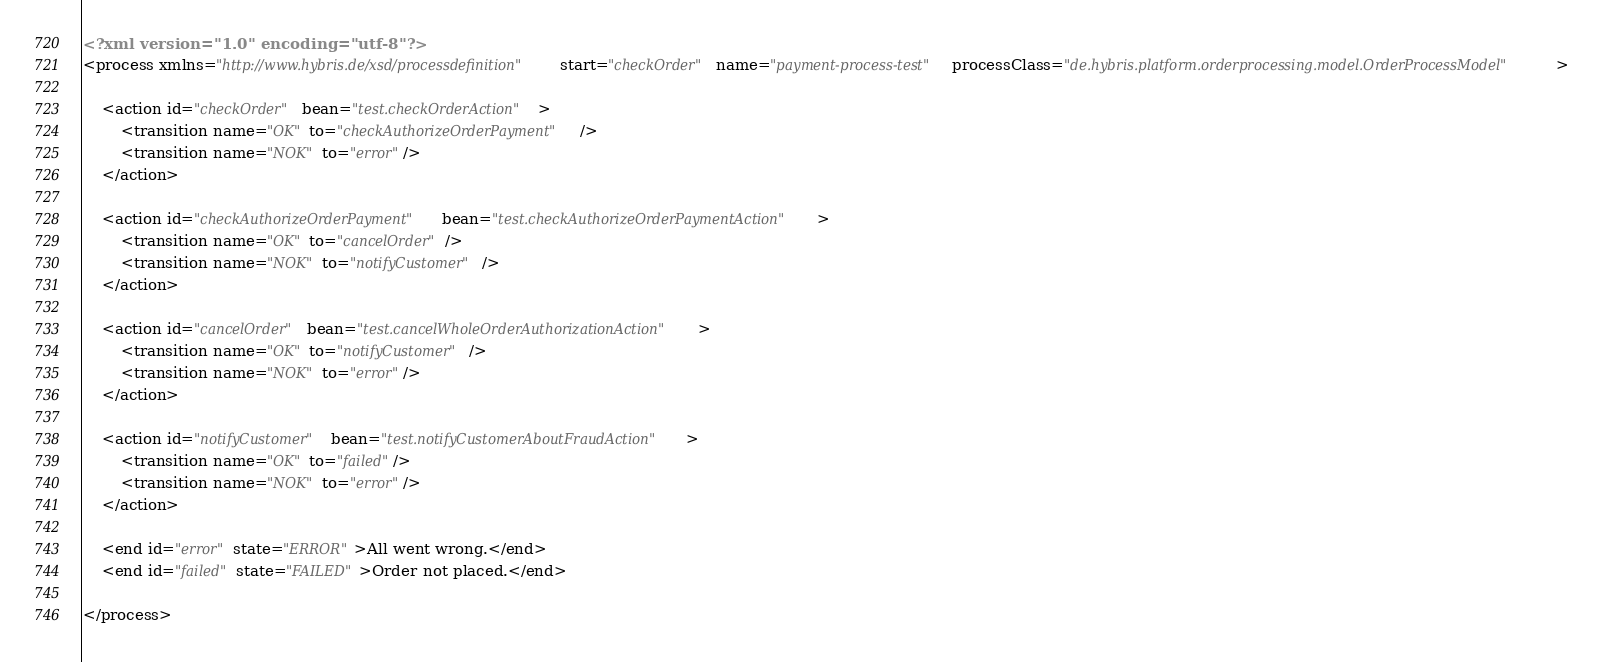Convert code to text. <code><loc_0><loc_0><loc_500><loc_500><_XML_><?xml version="1.0" encoding="utf-8"?>
<process xmlns="http://www.hybris.de/xsd/processdefinition" start="checkOrder" name="payment-process-test" processClass="de.hybris.platform.orderprocessing.model.OrderProcessModel">

	<action id="checkOrder" bean="test.checkOrderAction">
		<transition name="OK" to="checkAuthorizeOrderPayment"/>
		<transition name="NOK" to="error"/>
	</action>

	<action id="checkAuthorizeOrderPayment" bean="test.checkAuthorizeOrderPaymentAction">
		<transition name="OK" to="cancelOrder"/>
		<transition name="NOK" to="notifyCustomer"/>
	</action>

	<action id="cancelOrder" bean="test.cancelWholeOrderAuthorizationAction">
		<transition name="OK" to="notifyCustomer"/>
		<transition name="NOK" to="error"/>
	</action>

	<action id="notifyCustomer" bean="test.notifyCustomerAboutFraudAction">
		<transition name="OK" to="failed"/>
		<transition name="NOK" to="error"/>
	</action>

	<end id="error" state="ERROR">All went wrong.</end>
	<end id="failed" state="FAILED">Order not placed.</end>
	
</process></code> 